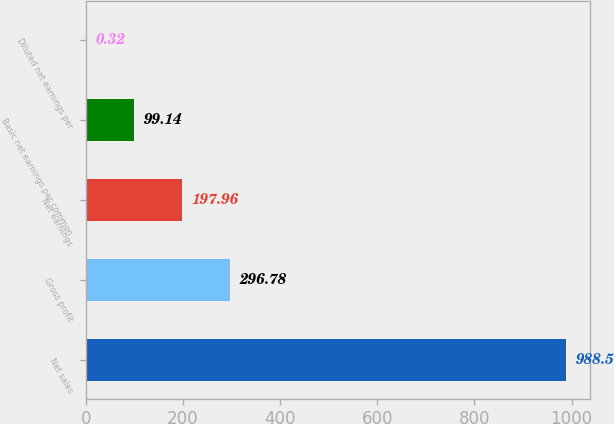Convert chart. <chart><loc_0><loc_0><loc_500><loc_500><bar_chart><fcel>Net sales<fcel>Gross profit<fcel>Net earnings<fcel>Basic net earnings per common<fcel>Diluted net earnings per<nl><fcel>988.5<fcel>296.78<fcel>197.96<fcel>99.14<fcel>0.32<nl></chart> 